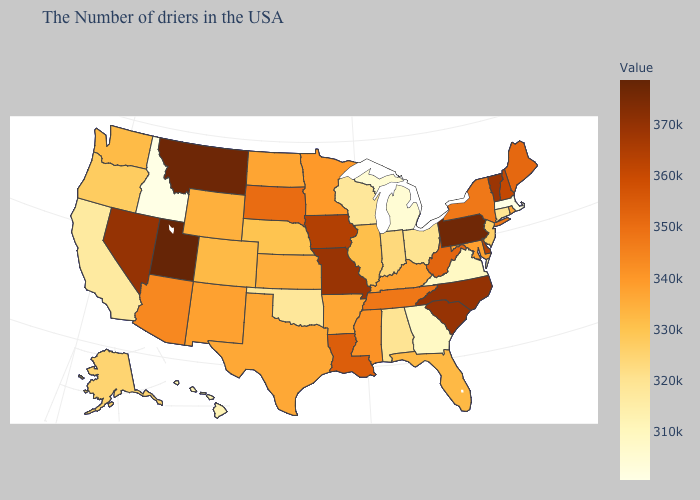Is the legend a continuous bar?
Keep it brief. Yes. Among the states that border Mississippi , does Alabama have the lowest value?
Concise answer only. Yes. Among the states that border Vermont , does Massachusetts have the lowest value?
Concise answer only. Yes. Does Arizona have a higher value than Pennsylvania?
Answer briefly. No. Which states have the highest value in the USA?
Keep it brief. Utah. 